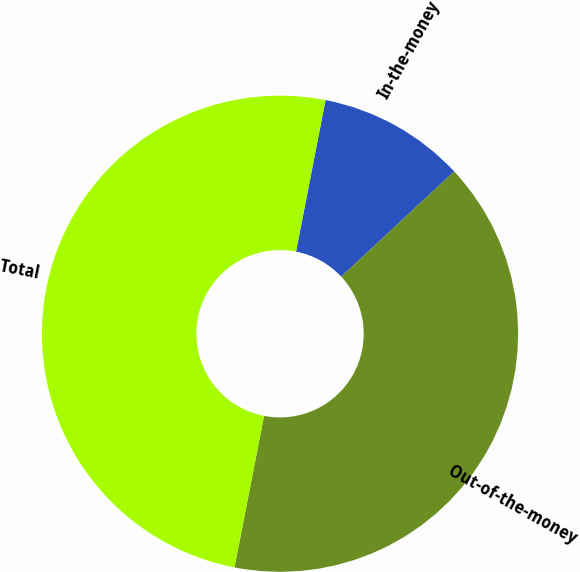Convert chart. <chart><loc_0><loc_0><loc_500><loc_500><pie_chart><fcel>In-the-money<fcel>Out-of-the-money<fcel>Total<nl><fcel>10.0%<fcel>40.0%<fcel>50.0%<nl></chart> 